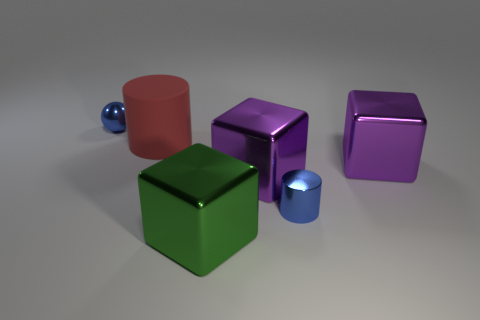There is a ball; are there any red rubber cylinders behind it?
Keep it short and to the point. No. What is the color of the small metal object that is the same shape as the large matte thing?
Your response must be concise. Blue. Is there anything else that is the same shape as the large green object?
Your answer should be very brief. Yes. What is the cylinder to the right of the big green metallic block made of?
Your response must be concise. Metal. There is a shiny object that is the same shape as the big red rubber thing; what size is it?
Your answer should be very brief. Small. How many small blue cylinders are the same material as the big green cube?
Provide a succinct answer. 1. How many large objects have the same color as the metal sphere?
Give a very brief answer. 0. How many things are blue balls on the left side of the big green shiny block or green shiny things that are in front of the big red object?
Your answer should be compact. 2. Is the number of metallic cubes left of the red cylinder less than the number of big brown matte cylinders?
Ensure brevity in your answer.  No. Are there any metallic cylinders that have the same size as the blue sphere?
Ensure brevity in your answer.  Yes. 